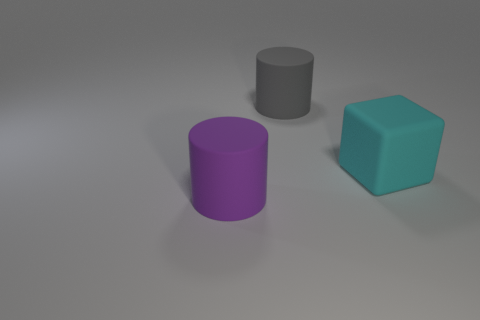Add 3 big purple cylinders. How many objects exist? 6 Subtract 1 blocks. How many blocks are left? 0 Subtract all gray cylinders. How many cylinders are left? 1 Subtract all cubes. How many objects are left? 2 Subtract 0 yellow spheres. How many objects are left? 3 Subtract all green cylinders. Subtract all gray blocks. How many cylinders are left? 2 Subtract all blue spheres. How many blue blocks are left? 0 Subtract all big gray objects. Subtract all cyan rubber cubes. How many objects are left? 1 Add 1 big purple matte cylinders. How many big purple matte cylinders are left? 2 Add 3 large purple objects. How many large purple objects exist? 4 